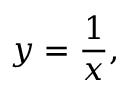Convert formula to latex. <formula><loc_0><loc_0><loc_500><loc_500>y = { \frac { 1 } { x } } ,</formula> 